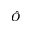<formula> <loc_0><loc_0><loc_500><loc_500>\hat { O }</formula> 